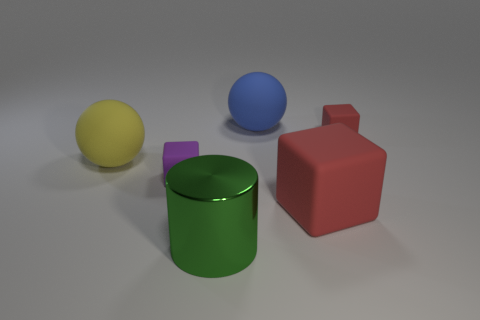Subtract all green balls. How many red blocks are left? 2 Subtract all red blocks. How many blocks are left? 1 Add 3 small red matte balls. How many objects exist? 9 Subtract all cylinders. How many objects are left? 5 Add 3 tiny red cubes. How many tiny red cubes are left? 4 Add 6 big red blocks. How many big red blocks exist? 7 Subtract 0 cyan cylinders. How many objects are left? 6 Subtract all tiny red matte cubes. Subtract all tiny purple rubber objects. How many objects are left? 4 